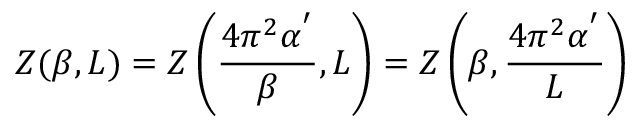Convert formula to latex. <formula><loc_0><loc_0><loc_500><loc_500>Z ( \beta , L ) = Z \left ( \frac { 4 \pi ^ { 2 } \alpha ^ { ^ { \prime } } } { \beta } , L \right ) = Z \left ( \beta , \frac { 4 \pi ^ { 2 } \alpha ^ { ^ { \prime } } } { L } \right )</formula> 